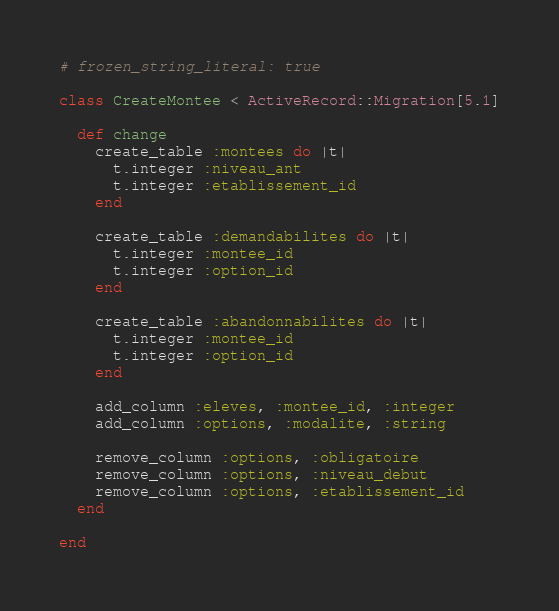Convert code to text. <code><loc_0><loc_0><loc_500><loc_500><_Ruby_># frozen_string_literal: true

class CreateMontee < ActiveRecord::Migration[5.1]

  def change
    create_table :montees do |t|
      t.integer :niveau_ant
      t.integer :etablissement_id
    end

    create_table :demandabilites do |t|
      t.integer :montee_id
      t.integer :option_id
    end

    create_table :abandonnabilites do |t|
      t.integer :montee_id
      t.integer :option_id
    end

    add_column :eleves, :montee_id, :integer
    add_column :options, :modalite, :string

    remove_column :options, :obligatoire
    remove_column :options, :niveau_debut
    remove_column :options, :etablissement_id
  end

end
</code> 